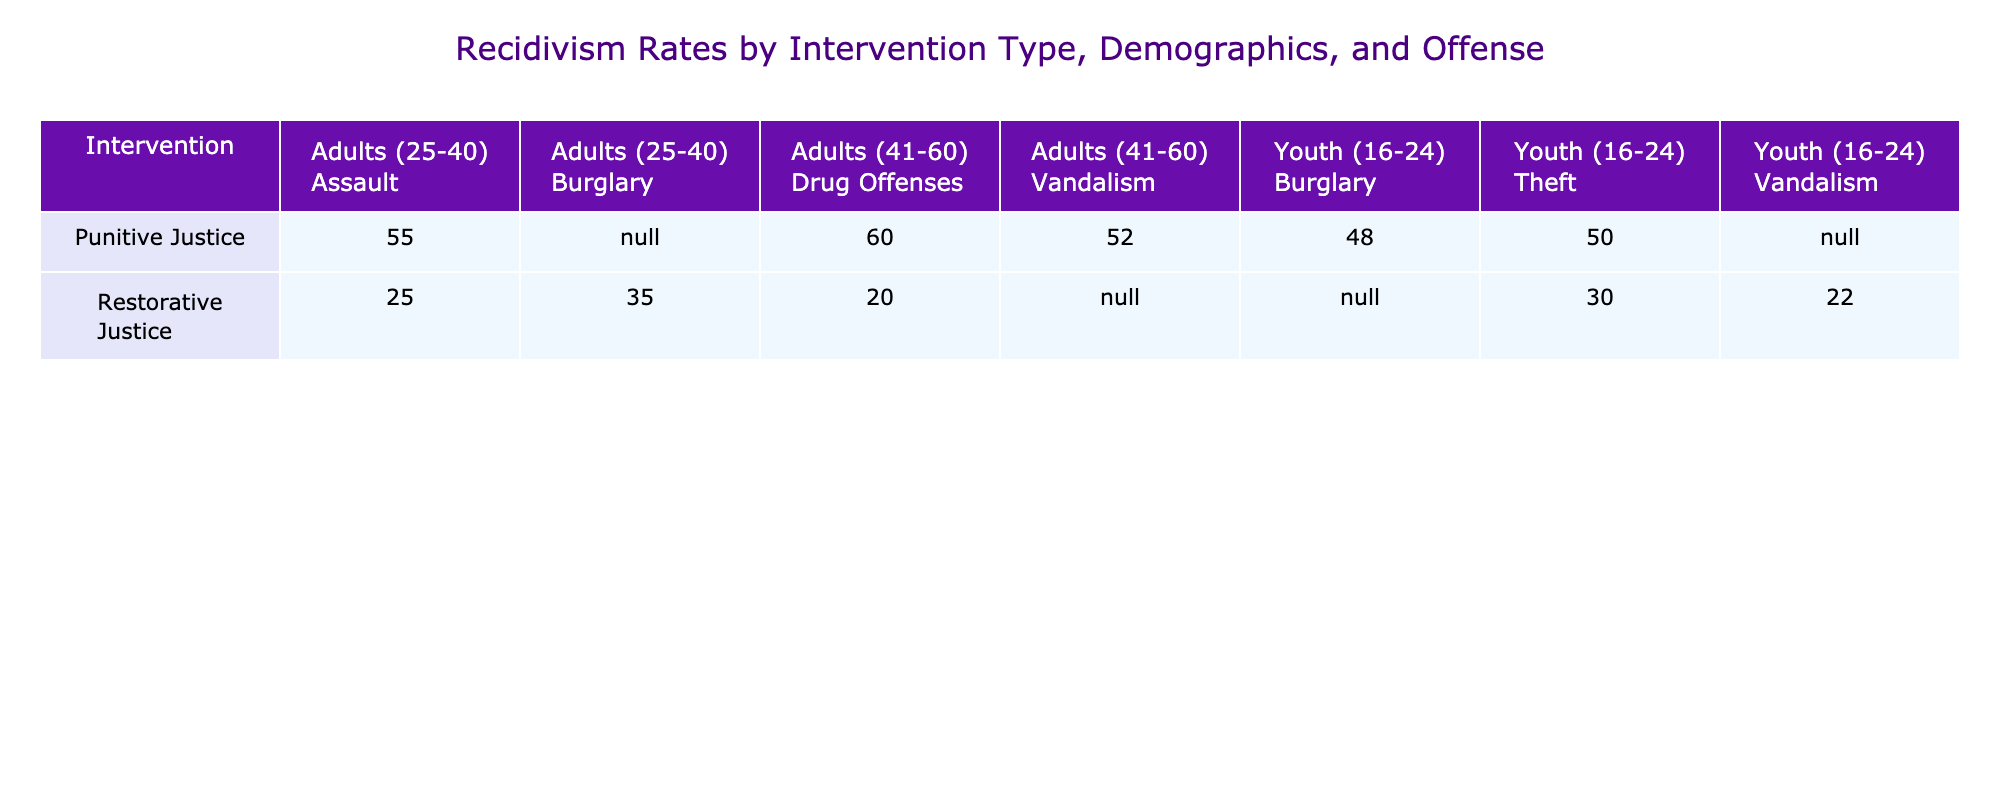What is the recidivism rate for youth related to theft under restorative justice? From the table, in the row where Intervention is "Restorative Justice" and Participant Demographics is "Youth (16-24)" with Type of Offense being "Theft," the recidivism rate is 30%.
Answer: 30% What is the recidivism rate for adults aged 41-60 for drug offenses under punitive justice? Looking at the row where Intervention is "Punitive Justice," Participant Demographics is "Adults (41-60)," and Type of Offense is "Drug Offenses," the recidivism rate is 60%.
Answer: 60% What is the average recidivism rate for all restorative justice interventions listed in the table? The restorative justice rates are 30, 25, 20, 35, and 22. The sum of these rates is 30 + 25 + 20 + 35 + 22 = 132. There are 5 entries, so the average is 132 / 5 = 26.4.
Answer: 26.4 Is the recidivism rate for adult assault cases higher under restorative or punitive justice? The rate for adult assault cases under restorative justice is 25%, while under punitive justice it is 55%. Since 55% is greater than 25%, the punitive justice rate is higher.
Answer: Yes Which type of intervention shows a lower recidivism rate for burglary offenses? For burglary, the restorative justice rate is 35%, and the punitive justice rate is 48%. Since 35% is lower than 48%, restorative justice shows a lower recidivism rate.
Answer: Restorative Justice What is the highest recidivism rate recorded for any intervention in the table? The highest rate in the table is 60%, noted for adults aged 41-60 under punitive justice for drug offenses.
Answer: 60% What is the difference in recidivism rates between youth theft offenses under punitive versus restorative justice? The recidivism rate for youth theft under restorative justice is 30%, and under punitive justice, it is 50%. The difference is 50 - 30 = 20%.
Answer: 20% Which demographic has the lowest recidivism rate for drug offenses, regardless of intervention type? Comparing both interventions for drug offenses, the lowest rate is seen in restorative justice for adults aged 41-60, which is 20%. All other demographics for drug offenses have a higher rate.
Answer: 20% What is the total recidivism rate for all punitive justice cases involving youth (16-24)? The rates for youth under punitive justice are 50% (theft) and 48% (burglary), which gives a total of 50 + 48 = 98%. To find the average, divide by 2, yielding 49%.
Answer: 49% 